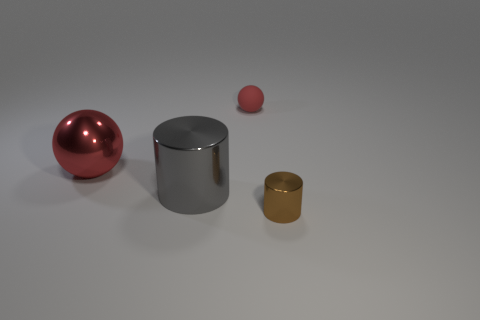What number of large cylinders have the same material as the large red sphere?
Give a very brief answer. 1. What color is the big object that is made of the same material as the gray cylinder?
Provide a succinct answer. Red. What material is the thing in front of the metallic cylinder that is behind the cylinder that is on the right side of the large gray metal thing made of?
Ensure brevity in your answer.  Metal. There is a object behind the shiny ball; does it have the same size as the big gray shiny cylinder?
Keep it short and to the point. No. What number of tiny things are either cyan cylinders or gray cylinders?
Provide a succinct answer. 0. Is there a small rubber ball that has the same color as the large metal sphere?
Provide a short and direct response. Yes. What is the shape of the thing that is the same size as the metal ball?
Make the answer very short. Cylinder. Does the small object that is on the left side of the small brown metallic thing have the same color as the big sphere?
Keep it short and to the point. Yes. What number of things are small things that are in front of the large gray cylinder or green cylinders?
Offer a very short reply. 1. Are there more red things behind the red shiny object than large red metal balls that are on the right side of the large cylinder?
Provide a short and direct response. Yes. 